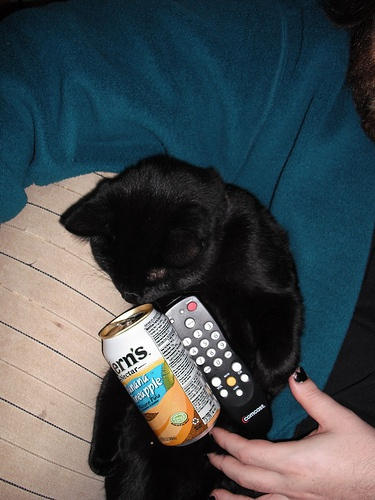Describe the objects in this image and their specific colors. I can see couch in black, darkblue, blue, and tan tones, cat in black, tan, gray, and darkgray tones, people in black, lightpink, gray, and salmon tones, and remote in black, darkgray, white, and gray tones in this image. 